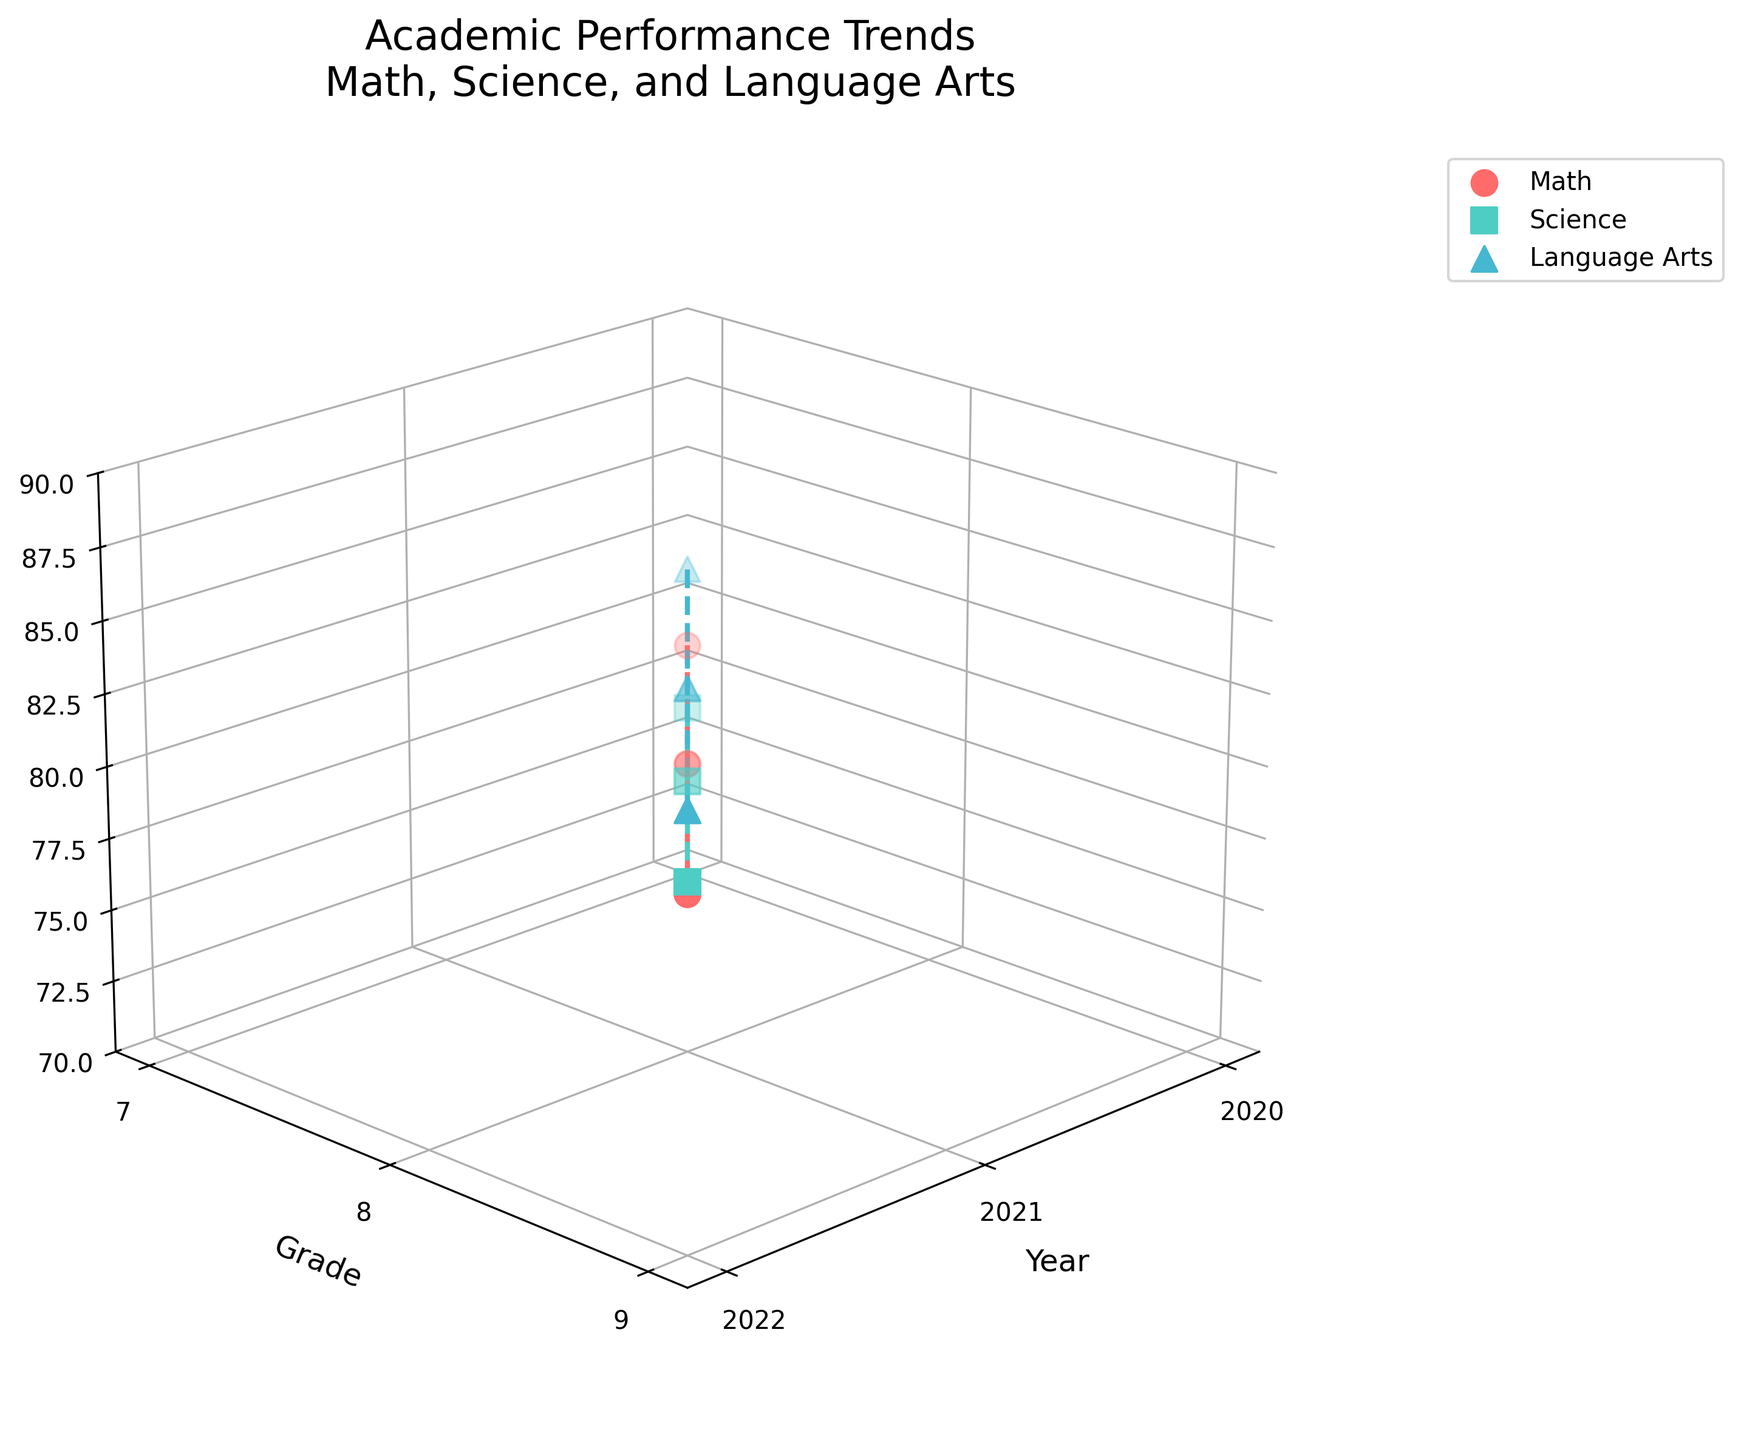what is the title of the plot? The title of the plot is visible at the top of the figure. From the information provided, the title is "Academic Performance Trends\nMath, Science, and Language Arts".
Answer: Academic Performance Trends\nMath, Science, and Language Arts Which subject has the highest average score in 2022? To find the highest average score in 2022, look at the data points for each subject (Math, Science, Language Arts) for the year 2022. Compare the average scores for each subject. Language Arts has the highest average score of 84.6 in 2022.
Answer: Language Arts How many years are represented in this figure? Examine the x-axis, which is labeled 'Year', to see the distinct values plotted. The years represented are 2020, 2021, and 2022.
Answer: Three What is the average score trend for science over three years? Observe the data points and the connecting line for Science. The average scores are 76.2 in 2020, 79.5 in 2021, and 82.3 in 2022, showing an upward trend each year.
Answer: Upward trend Which subject shows the most consistent year-over-year improvement? Evaluate each subject's average scores year-over-year. Math improves from 78.5 to 80.1 to 81.9, Science from 76.2 to 79.5 to 82.3, and Language Arts from 81.3 to 82.7 to 84.6. All three show improvement, but Math and Science have smaller year-over-year increases, and Language Arts shows the highest consistency in improvement (less variation).
Answer: Language Arts In which grade did Science see the largest improvement in average score? Compare the Science average scores for each grade increase. From Grade 7 to Grade 8, it improves from 76.2 to 79.5 (an increase of 3.3); from Grade 8 to Grade 9, it improves from 79.5 to 82.3 (an increase of 2.8). The largest improvement is from Grade 7 to Grade 8.
Answer: Grade 7 to Grade 8 What is the total increase in average score for Math from 2020 to 2022? The Math average score in 2020 is 78.5, and in 2022 it is 81.9. The total increase is 81.9 - 78.5 = 3.4.
Answer: 3.4 Which subject had an average score below 80 in all three years? Examine the average scores of all subjects for each year. Math scores are 78.5 (2020), 80.1 (2021), and 81.9 (2022); Science scores are 76.2 (2020), 79.5 (2021), and 82.3 (2022); Language Arts scores are 81.3 (2020), 82.7 (2021), and 84.6 (2022). Science is the only subject with scores below 80 in all three years.
Answer: Science 